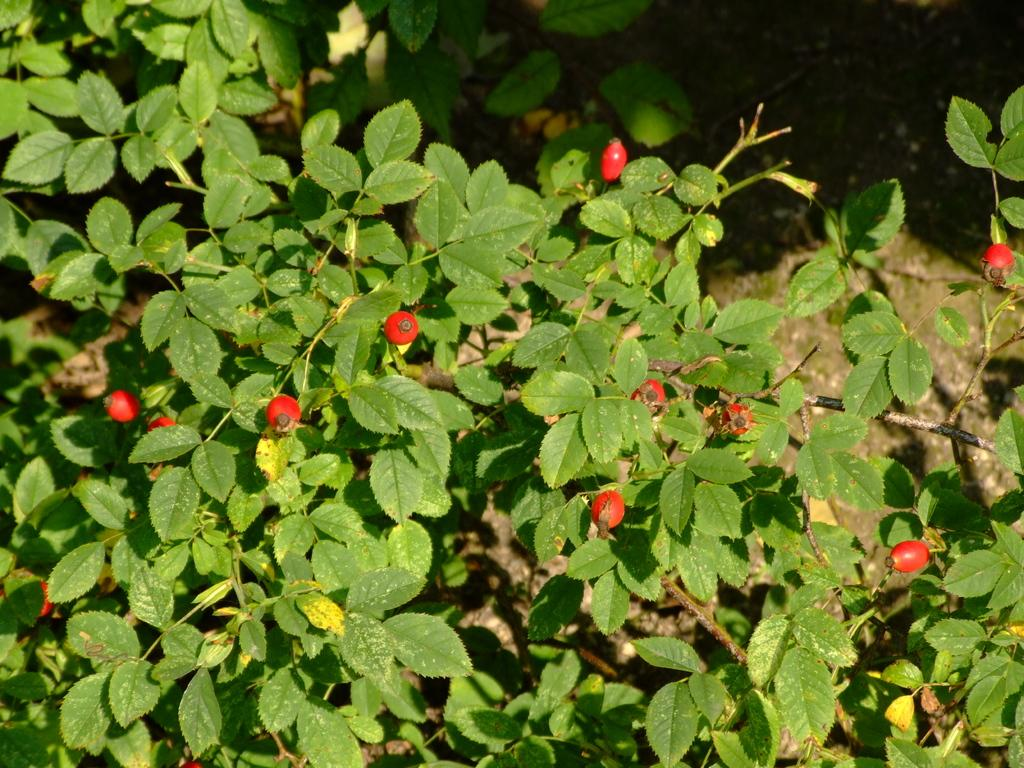What type of living organisms can be seen in the image? Plants can be seen in the image. What type of cheese is being served in the school cafeteria in the image? There is no mention of cheese or a school cafeteria in the image, as it only features plants. 